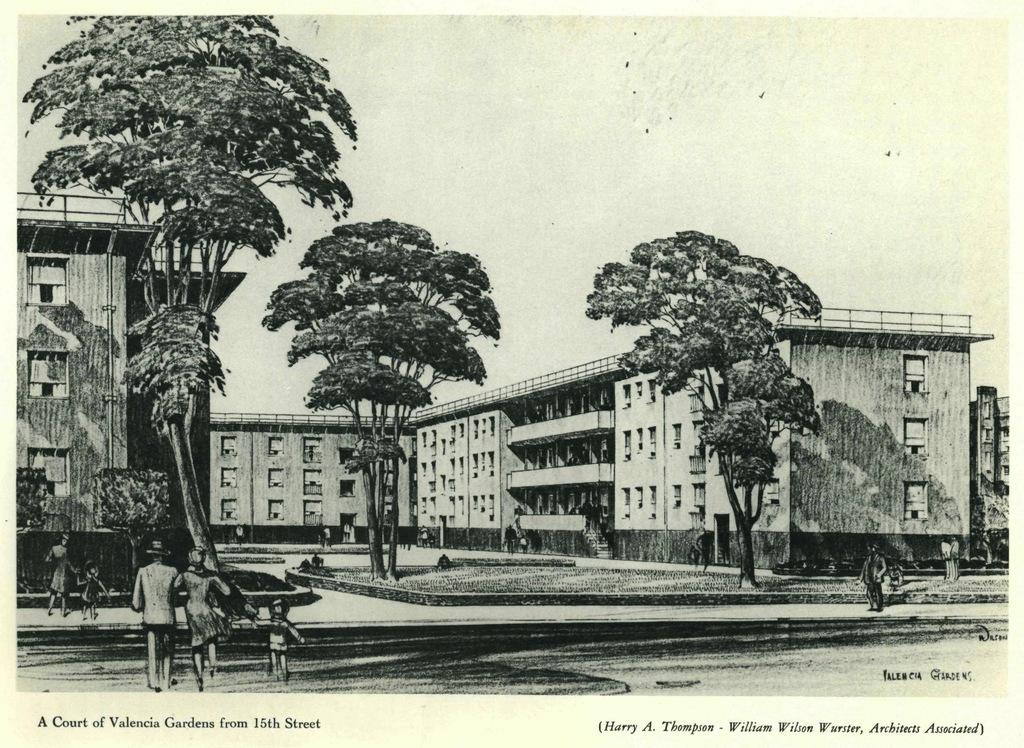What is the main subject of the image? The main subject of the image is a photocopy of a building. Are there any other buildings visible in the image? Yes, there are buildings in the image. What else can be seen in the image besides buildings? There are trees and people walking in the image. What is written or printed at the bottom of the image? There is text at the bottom of the image. How many bags can be seen in the image during the rainstorm? There is no rainstorm depicted in the image, and no bags are visible. 